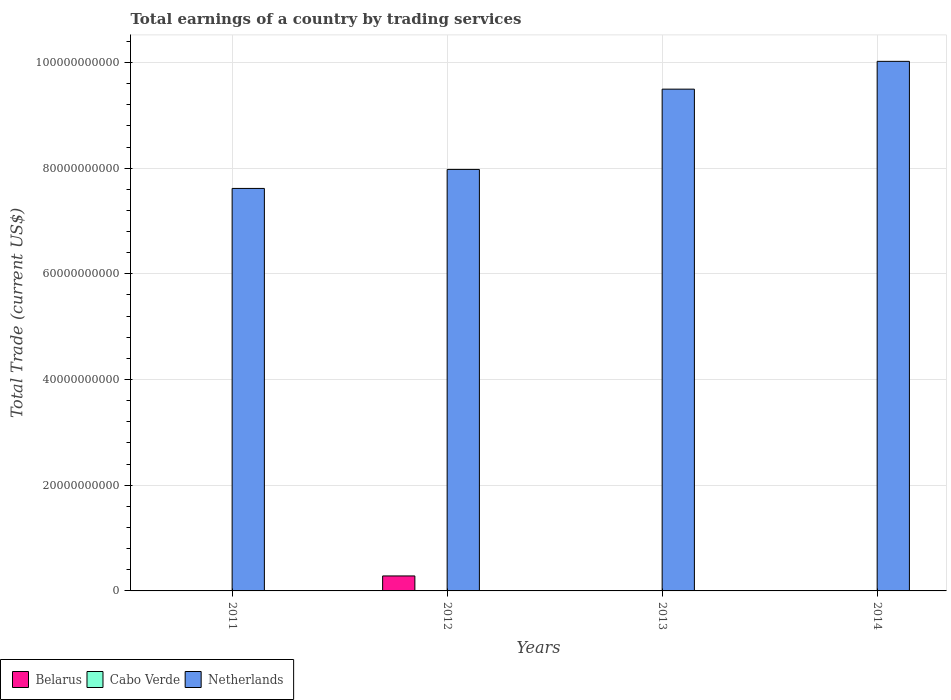Are the number of bars per tick equal to the number of legend labels?
Provide a short and direct response. No. Are the number of bars on each tick of the X-axis equal?
Give a very brief answer. No. How many bars are there on the 4th tick from the left?
Ensure brevity in your answer.  1. How many bars are there on the 4th tick from the right?
Offer a terse response. 1. What is the label of the 4th group of bars from the left?
Make the answer very short. 2014. What is the total earnings in Netherlands in 2013?
Ensure brevity in your answer.  9.50e+1. Across all years, what is the maximum total earnings in Netherlands?
Offer a terse response. 1.00e+11. What is the difference between the total earnings in Netherlands in 2012 and that in 2013?
Provide a short and direct response. -1.52e+1. What is the difference between the total earnings in Cabo Verde in 2011 and the total earnings in Netherlands in 2012?
Your answer should be very brief. -7.98e+1. What is the average total earnings in Netherlands per year?
Offer a very short reply. 8.78e+1. In the year 2012, what is the difference between the total earnings in Netherlands and total earnings in Belarus?
Give a very brief answer. 7.69e+1. What is the ratio of the total earnings in Netherlands in 2011 to that in 2013?
Ensure brevity in your answer.  0.8. What is the difference between the highest and the second highest total earnings in Netherlands?
Your answer should be very brief. 5.26e+09. What is the difference between the highest and the lowest total earnings in Netherlands?
Your response must be concise. 2.40e+1. Is the sum of the total earnings in Netherlands in 2013 and 2014 greater than the maximum total earnings in Belarus across all years?
Make the answer very short. Yes. Is it the case that in every year, the sum of the total earnings in Belarus and total earnings in Cabo Verde is greater than the total earnings in Netherlands?
Provide a short and direct response. No. How many bars are there?
Your response must be concise. 5. What is the difference between two consecutive major ticks on the Y-axis?
Provide a short and direct response. 2.00e+1. Does the graph contain any zero values?
Offer a terse response. Yes. Does the graph contain grids?
Offer a terse response. Yes. Where does the legend appear in the graph?
Ensure brevity in your answer.  Bottom left. What is the title of the graph?
Offer a very short reply. Total earnings of a country by trading services. What is the label or title of the X-axis?
Provide a short and direct response. Years. What is the label or title of the Y-axis?
Your answer should be compact. Total Trade (current US$). What is the Total Trade (current US$) in Belarus in 2011?
Give a very brief answer. 0. What is the Total Trade (current US$) in Netherlands in 2011?
Your answer should be very brief. 7.62e+1. What is the Total Trade (current US$) of Belarus in 2012?
Ensure brevity in your answer.  2.83e+09. What is the Total Trade (current US$) in Cabo Verde in 2012?
Offer a very short reply. 0. What is the Total Trade (current US$) in Netherlands in 2012?
Offer a terse response. 7.98e+1. What is the Total Trade (current US$) of Belarus in 2013?
Your answer should be very brief. 0. What is the Total Trade (current US$) in Cabo Verde in 2013?
Provide a succinct answer. 0. What is the Total Trade (current US$) in Netherlands in 2013?
Give a very brief answer. 9.50e+1. What is the Total Trade (current US$) in Netherlands in 2014?
Give a very brief answer. 1.00e+11. Across all years, what is the maximum Total Trade (current US$) of Belarus?
Your answer should be very brief. 2.83e+09. Across all years, what is the maximum Total Trade (current US$) in Netherlands?
Make the answer very short. 1.00e+11. Across all years, what is the minimum Total Trade (current US$) in Belarus?
Your response must be concise. 0. Across all years, what is the minimum Total Trade (current US$) of Netherlands?
Keep it short and to the point. 7.62e+1. What is the total Total Trade (current US$) in Belarus in the graph?
Make the answer very short. 2.83e+09. What is the total Total Trade (current US$) in Cabo Verde in the graph?
Offer a very short reply. 0. What is the total Total Trade (current US$) of Netherlands in the graph?
Keep it short and to the point. 3.51e+11. What is the difference between the Total Trade (current US$) in Netherlands in 2011 and that in 2012?
Keep it short and to the point. -3.59e+09. What is the difference between the Total Trade (current US$) of Netherlands in 2011 and that in 2013?
Make the answer very short. -1.88e+1. What is the difference between the Total Trade (current US$) of Netherlands in 2011 and that in 2014?
Your answer should be very brief. -2.40e+1. What is the difference between the Total Trade (current US$) in Netherlands in 2012 and that in 2013?
Offer a very short reply. -1.52e+1. What is the difference between the Total Trade (current US$) in Netherlands in 2012 and that in 2014?
Give a very brief answer. -2.05e+1. What is the difference between the Total Trade (current US$) of Netherlands in 2013 and that in 2014?
Offer a very short reply. -5.26e+09. What is the difference between the Total Trade (current US$) of Belarus in 2012 and the Total Trade (current US$) of Netherlands in 2013?
Give a very brief answer. -9.21e+1. What is the difference between the Total Trade (current US$) in Belarus in 2012 and the Total Trade (current US$) in Netherlands in 2014?
Your response must be concise. -9.74e+1. What is the average Total Trade (current US$) of Belarus per year?
Offer a very short reply. 7.08e+08. What is the average Total Trade (current US$) in Cabo Verde per year?
Your answer should be very brief. 0. What is the average Total Trade (current US$) of Netherlands per year?
Offer a very short reply. 8.78e+1. In the year 2012, what is the difference between the Total Trade (current US$) of Belarus and Total Trade (current US$) of Netherlands?
Offer a very short reply. -7.69e+1. What is the ratio of the Total Trade (current US$) of Netherlands in 2011 to that in 2012?
Offer a terse response. 0.95. What is the ratio of the Total Trade (current US$) of Netherlands in 2011 to that in 2013?
Provide a short and direct response. 0.8. What is the ratio of the Total Trade (current US$) of Netherlands in 2011 to that in 2014?
Offer a very short reply. 0.76. What is the ratio of the Total Trade (current US$) in Netherlands in 2012 to that in 2013?
Give a very brief answer. 0.84. What is the ratio of the Total Trade (current US$) in Netherlands in 2012 to that in 2014?
Keep it short and to the point. 0.8. What is the ratio of the Total Trade (current US$) in Netherlands in 2013 to that in 2014?
Ensure brevity in your answer.  0.95. What is the difference between the highest and the second highest Total Trade (current US$) in Netherlands?
Provide a short and direct response. 5.26e+09. What is the difference between the highest and the lowest Total Trade (current US$) of Belarus?
Offer a terse response. 2.83e+09. What is the difference between the highest and the lowest Total Trade (current US$) of Netherlands?
Provide a short and direct response. 2.40e+1. 